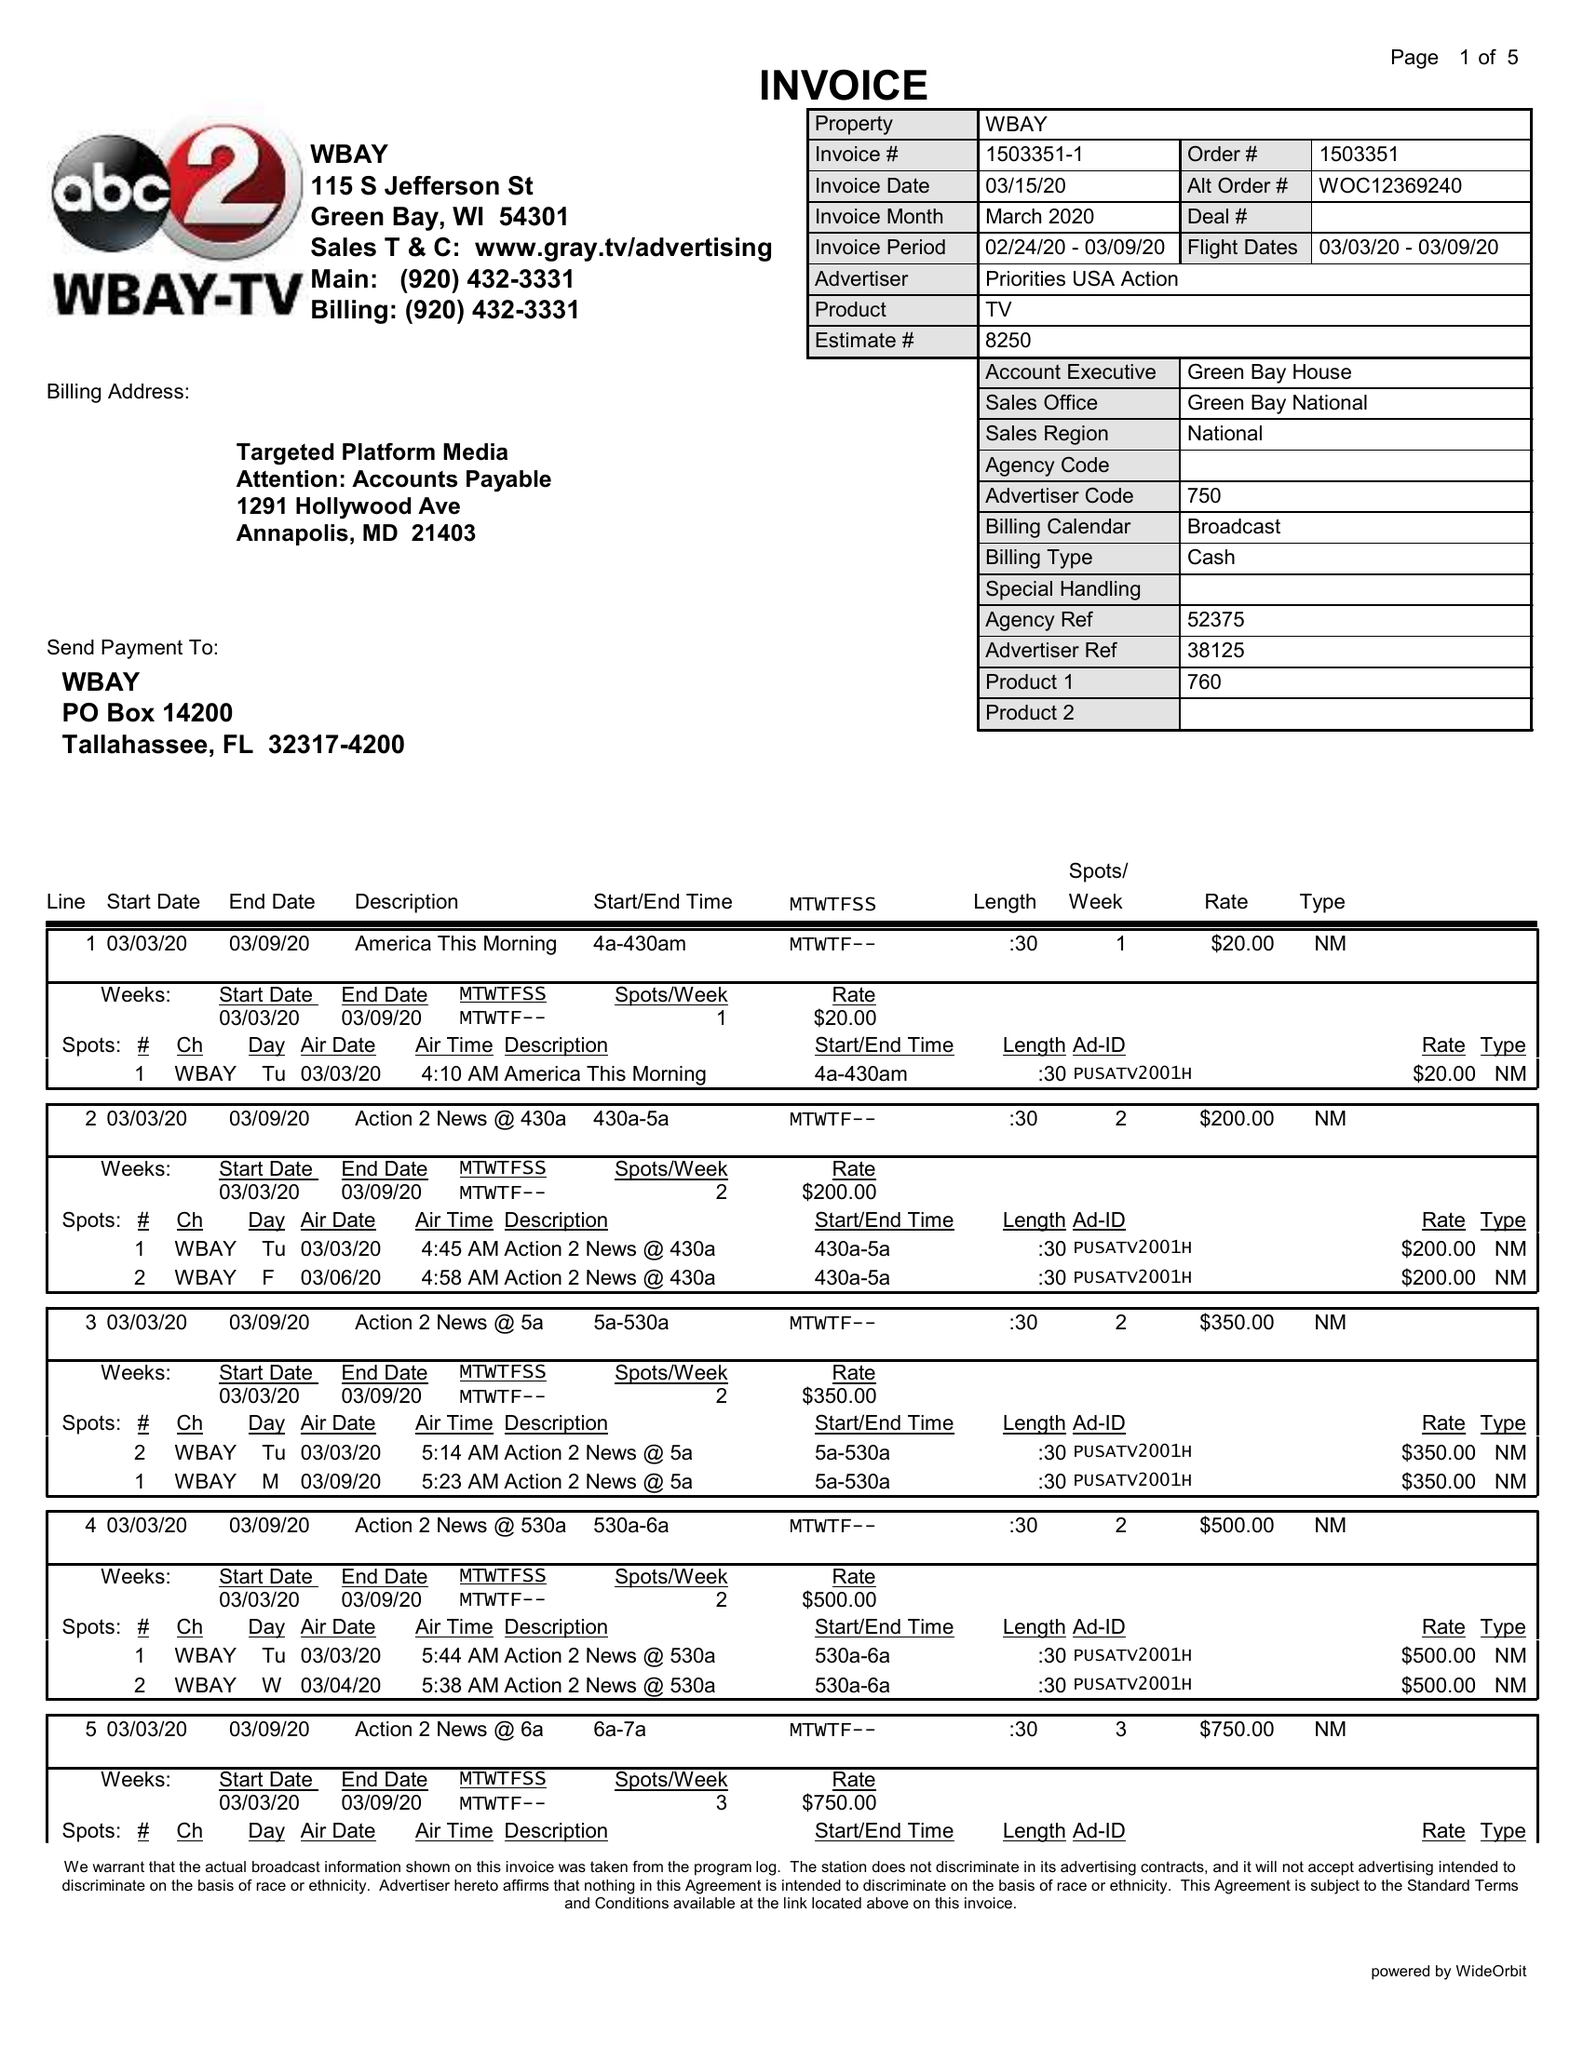What is the value for the gross_amount?
Answer the question using a single word or phrase. 31680.00 